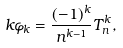<formula> <loc_0><loc_0><loc_500><loc_500>k \varphi _ { k } = \frac { ( - 1 ) ^ { k } } { n ^ { k - 1 } } T _ { n } ^ { k } ,</formula> 